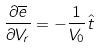<formula> <loc_0><loc_0><loc_500><loc_500>\frac { \partial \overline { e } } { \partial V _ { r } } = - \frac { 1 } { V _ { 0 } } \hat { t }</formula> 